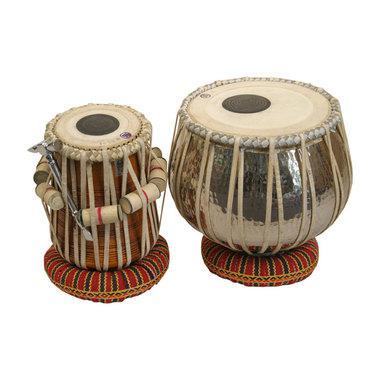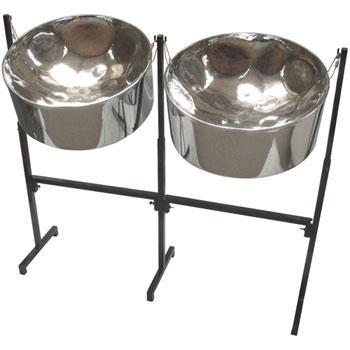The first image is the image on the left, the second image is the image on the right. For the images displayed, is the sentence "a set of drums have a dark circle on top, and leather strips around the drum holding wooden dowels" factually correct? Answer yes or no. Yes. The first image is the image on the left, the second image is the image on the right. For the images shown, is this caption "One image features a pair of drums wrapped in pale cord, with pillow bases and flat tops with black dots in the center, and the other image is a pair of side-by-side shiny bowl-shaped steel drums." true? Answer yes or no. Yes. 